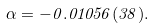Convert formula to latex. <formula><loc_0><loc_0><loc_500><loc_500>\alpha = - 0 . 0 1 0 5 6 ( 3 8 ) .</formula> 